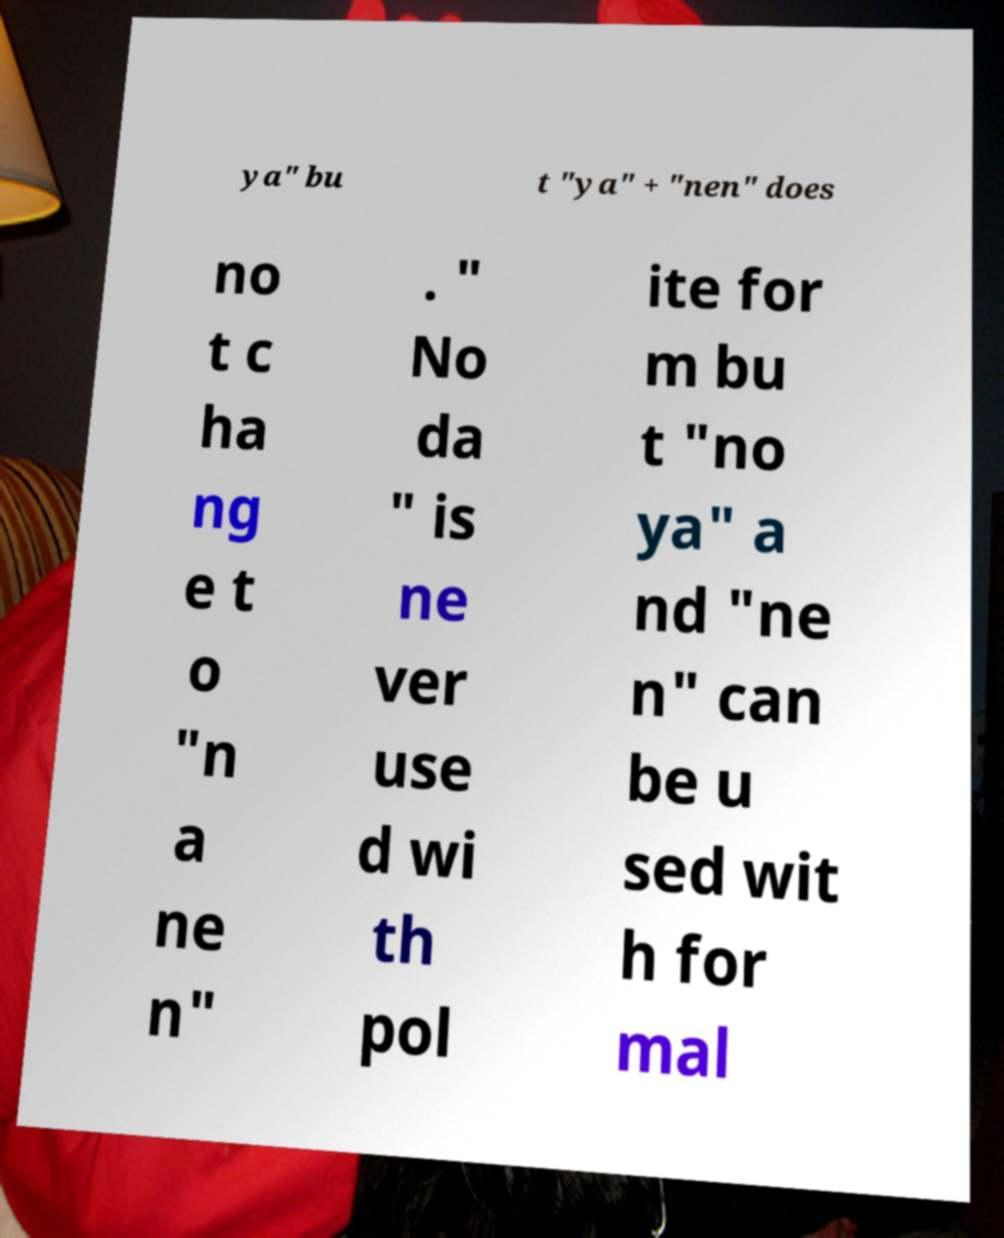There's text embedded in this image that I need extracted. Can you transcribe it verbatim? ya" bu t "ya" + "nen" does no t c ha ng e t o "n a ne n" . " No da " is ne ver use d wi th pol ite for m bu t "no ya" a nd "ne n" can be u sed wit h for mal 